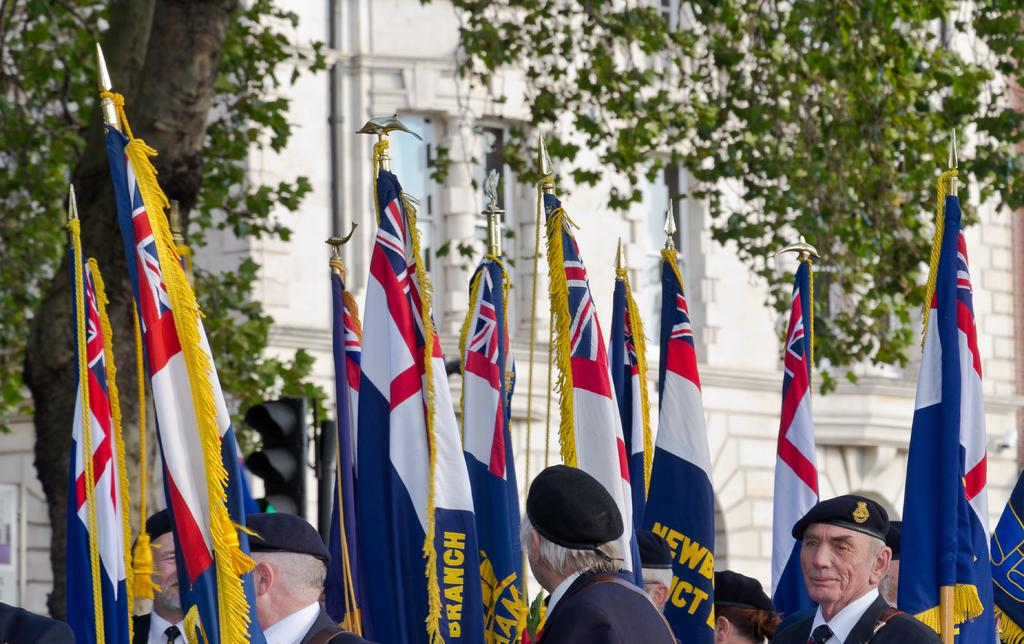What can be seen flying in the image? There are flags in the image. What are the people in the image doing? The people are wearing caps and are likely part of a group activity. What is visible in the background of the image? There is a traffic light, trees, and a building in the background of the image. Can you see a baby wearing a boot in the image? There is no baby or boot present in the image. 